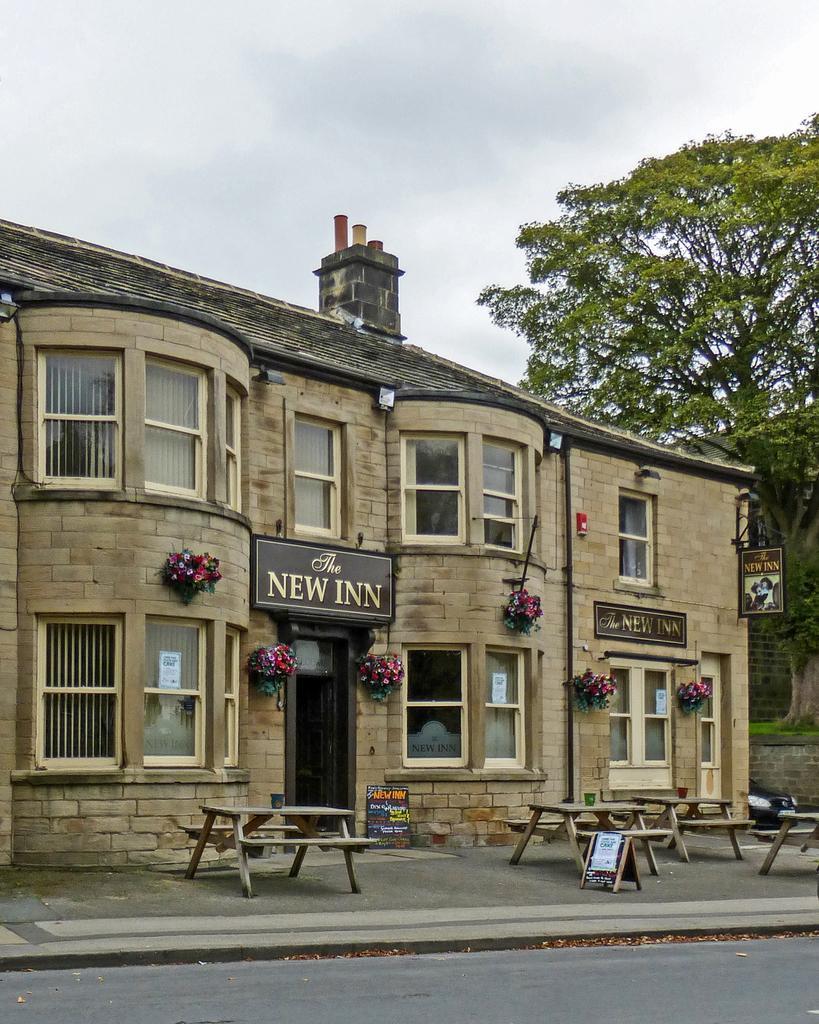How would you summarize this image in a sentence or two? In this image, I can see a building with name boards, windows and plants with flowers. In front of the building, I can see picnic tables and boards. On the right side of the image, there is a tree and a vehicle. In the background, I can see the sky. At the bottom of the image, I can see a road. 